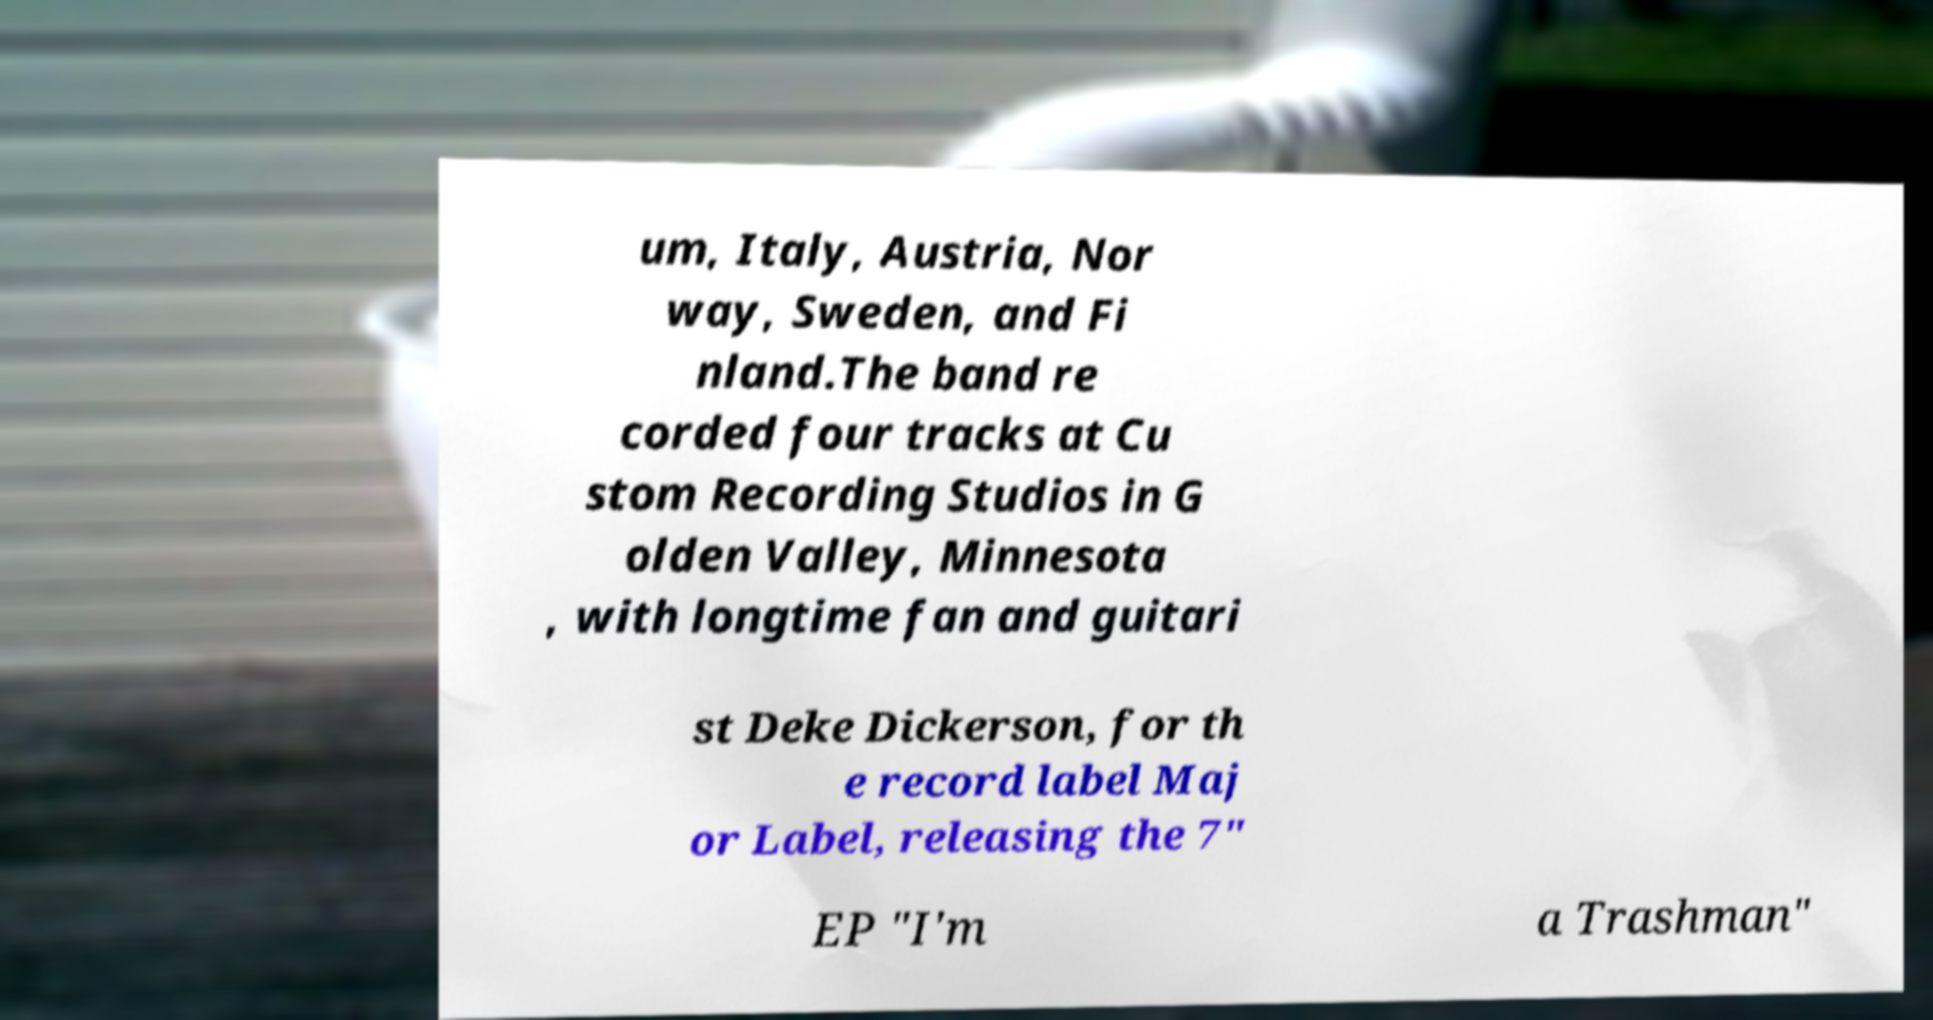Please read and relay the text visible in this image. What does it say? um, Italy, Austria, Nor way, Sweden, and Fi nland.The band re corded four tracks at Cu stom Recording Studios in G olden Valley, Minnesota , with longtime fan and guitari st Deke Dickerson, for th e record label Maj or Label, releasing the 7" EP "I'm a Trashman" 